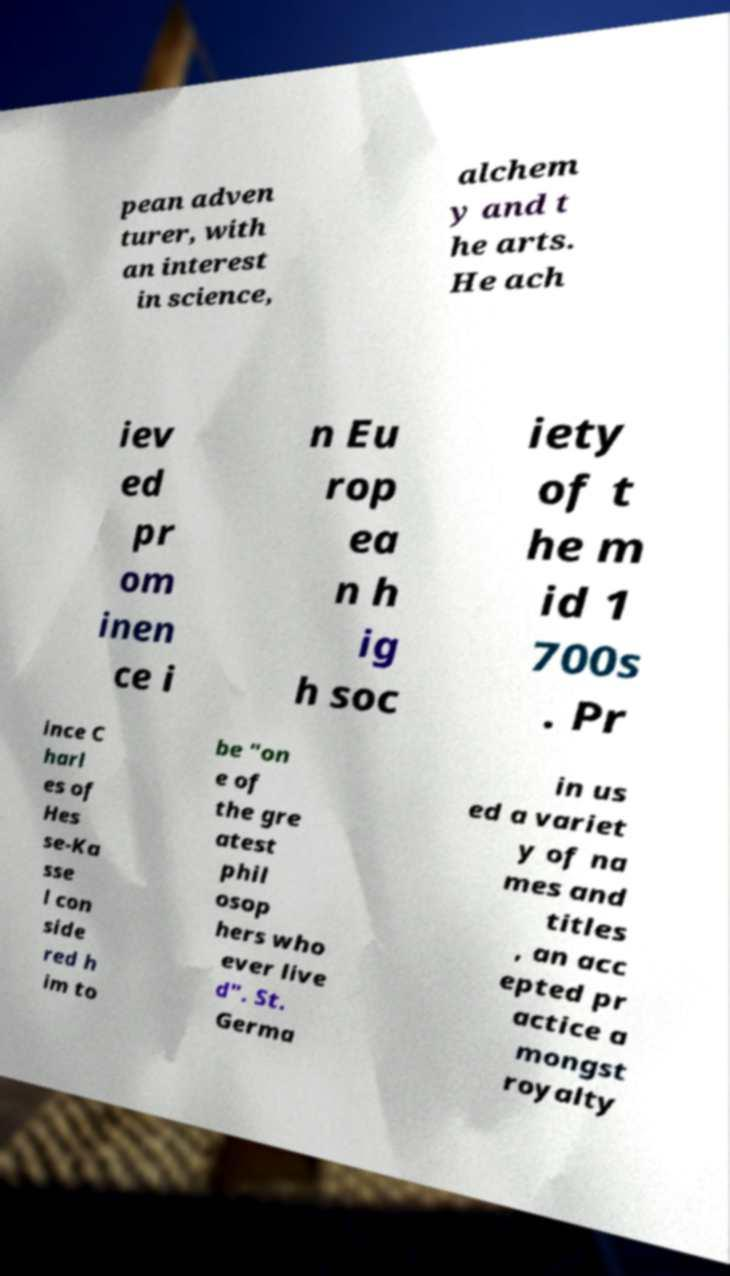Could you assist in decoding the text presented in this image and type it out clearly? pean adven turer, with an interest in science, alchem y and t he arts. He ach iev ed pr om inen ce i n Eu rop ea n h ig h soc iety of t he m id 1 700s . Pr ince C harl es of Hes se-Ka sse l con side red h im to be "on e of the gre atest phil osop hers who ever live d". St. Germa in us ed a variet y of na mes and titles , an acc epted pr actice a mongst royalty 